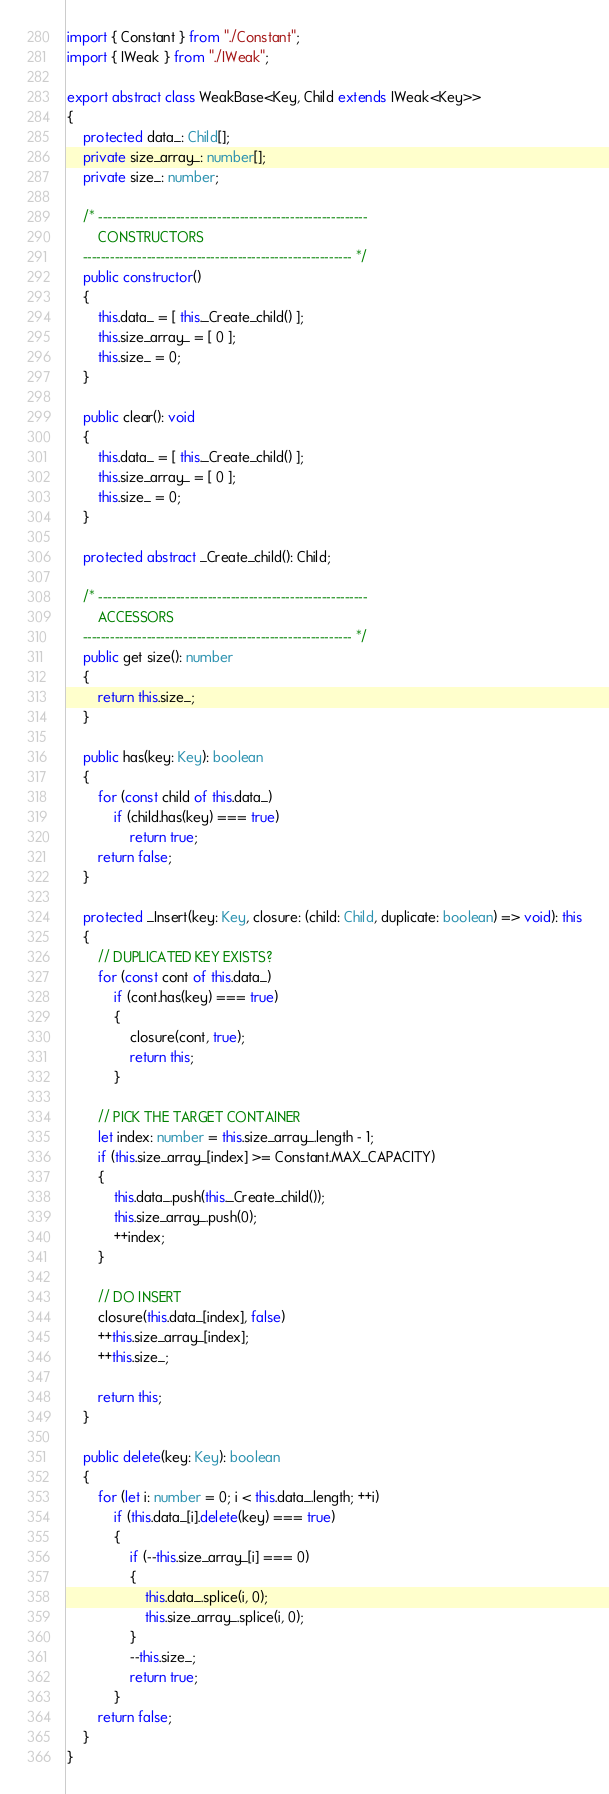Convert code to text. <code><loc_0><loc_0><loc_500><loc_500><_TypeScript_>import { Constant } from "./Constant";
import { IWeak } from "./IWeak";

export abstract class WeakBase<Key, Child extends IWeak<Key>>
{
    protected data_: Child[];
    private size_array_: number[];
    private size_: number;

    /* -----------------------------------------------------------
        CONSTRUCTORS
    ----------------------------------------------------------- */
    public constructor()
    {
        this.data_ = [ this._Create_child() ];
        this.size_array_ = [ 0 ];
        this.size_ = 0;
    }
    
    public clear(): void
    {
        this.data_ = [ this._Create_child() ];
        this.size_array_ = [ 0 ];
        this.size_ = 0;
    }

    protected abstract _Create_child(): Child;

    /* -----------------------------------------------------------
        ACCESSORS
    ----------------------------------------------------------- */
    public get size(): number
    {
        return this.size_;
    }

    public has(key: Key): boolean
    {
        for (const child of this.data_)
            if (child.has(key) === true)
                return true;
        return false;
    }

    protected _Insert(key: Key, closure: (child: Child, duplicate: boolean) => void): this
    {
        // DUPLICATED KEY EXISTS?
        for (const cont of this.data_)
            if (cont.has(key) === true)
            {
                closure(cont, true);
                return this;
            }

        // PICK THE TARGET CONTAINER
        let index: number = this.size_array_.length - 1;
        if (this.size_array_[index] >= Constant.MAX_CAPACITY)
        {
            this.data_.push(this._Create_child());
            this.size_array_.push(0);
            ++index;
        }

        // DO INSERT
        closure(this.data_[index], false)
        ++this.size_array_[index];
        ++this.size_;

        return this;
    }

    public delete(key: Key): boolean
    {
        for (let i: number = 0; i < this.data_.length; ++i)
            if (this.data_[i].delete(key) === true)
            {
                if (--this.size_array_[i] === 0)
                {
                    this.data_.splice(i, 0);
                    this.size_array_.splice(i, 0);
                }
                --this.size_;
                return true;
            }
        return false;
    }
}</code> 